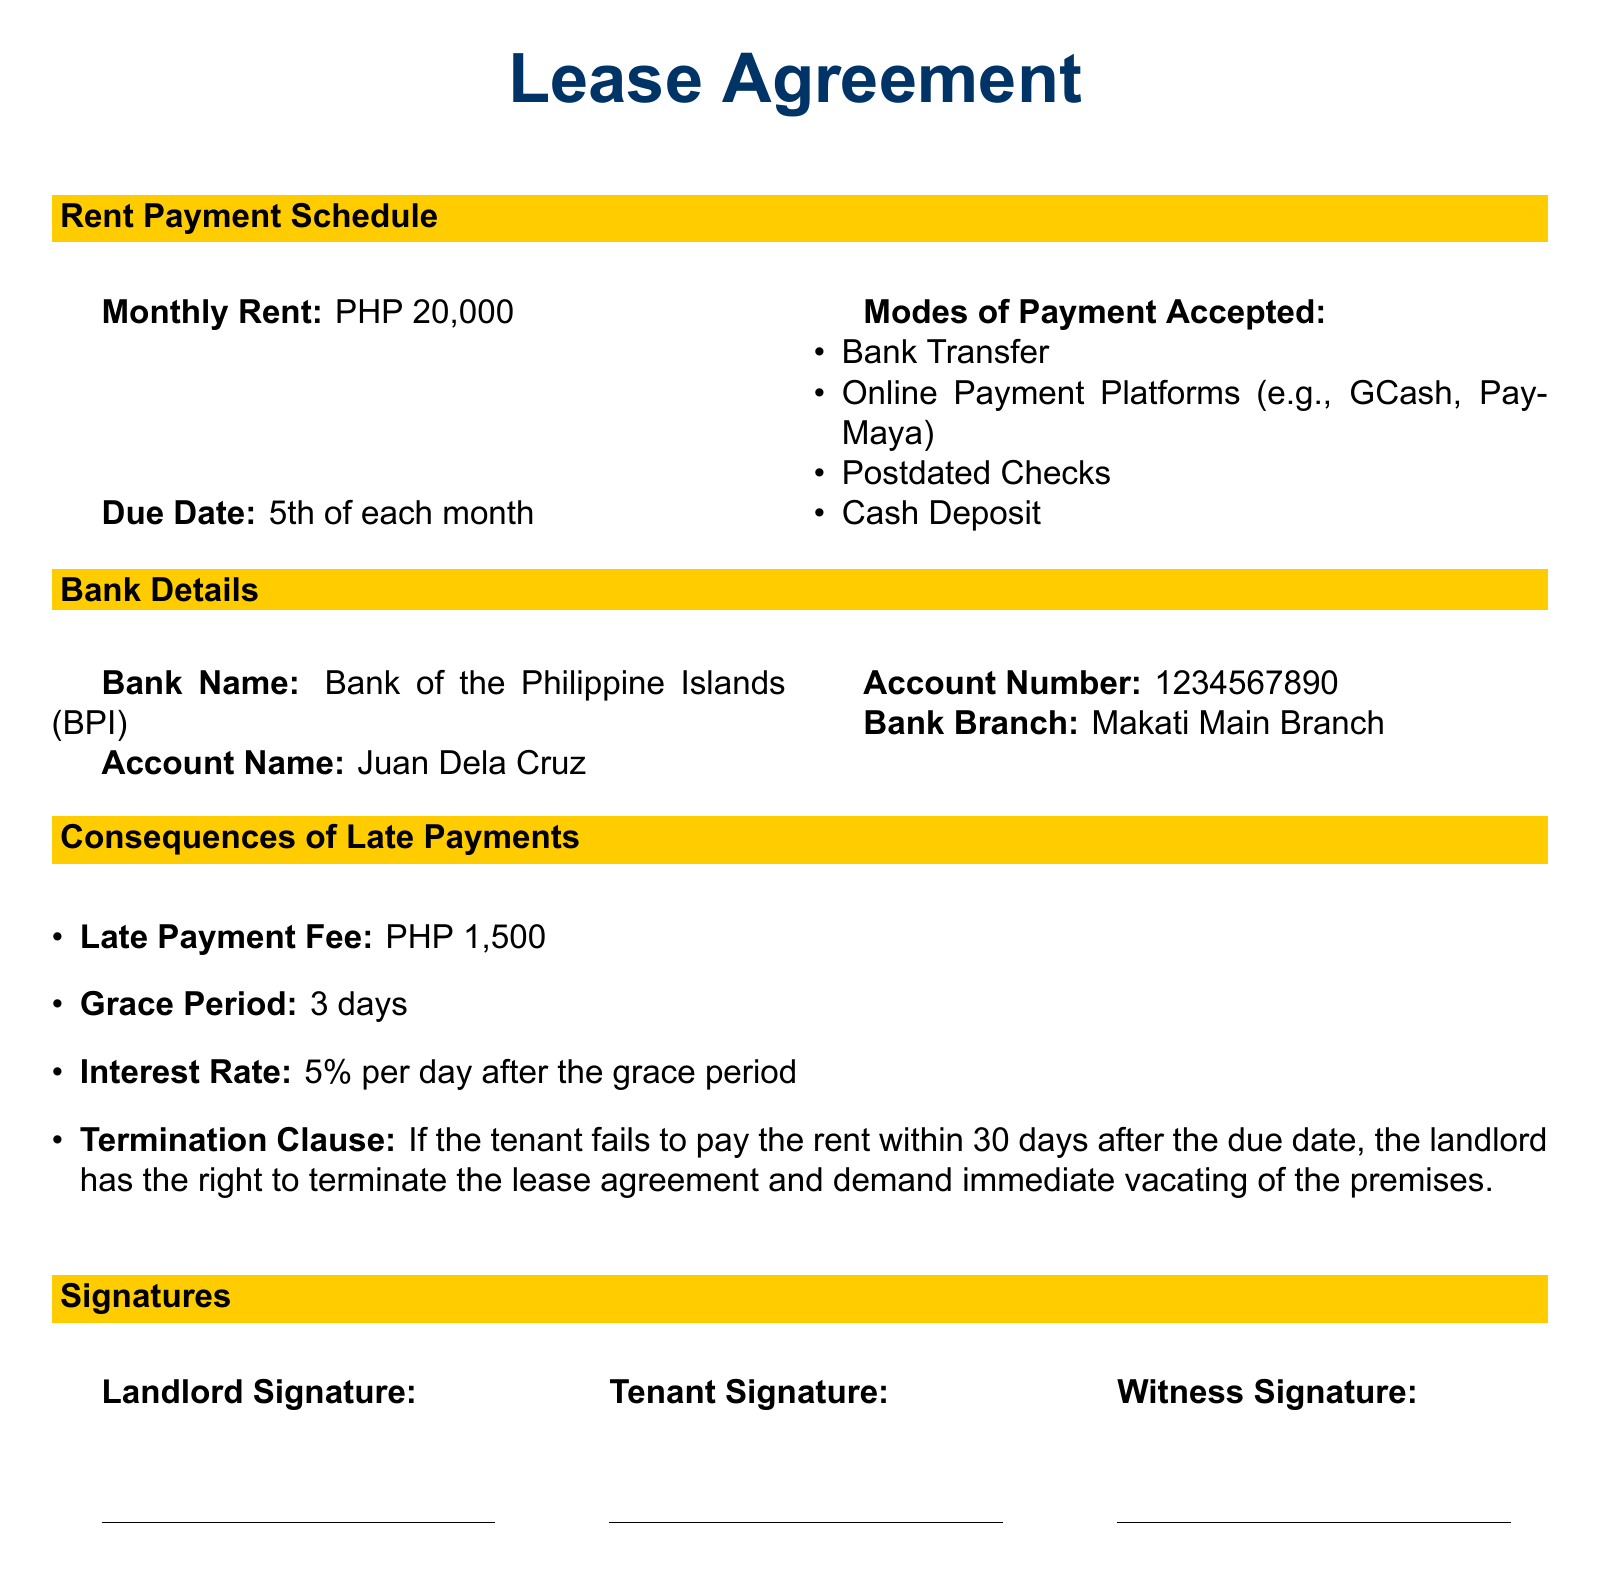What is the monthly rent? The monthly rent is stated explicitly in the document.
Answer: PHP 20,000 When is the rent due? The due date for rent is specified in the payment schedule.
Answer: 5th of each month What are the accepted modes of payment? The document lists the acceptable payment methods in a bullet format.
Answer: Bank Transfer, Online Payment Platforms, Postdated Checks, Cash Deposit What is the late payment fee? The document specifies the penalty for late payments clearly.
Answer: PHP 1,500 What is the grace period for late payments? The grace period is mentioned explicitly in the consequences section.
Answer: 3 days What is the interest rate after the grace period? The document states the interest rate applicable for late payments.
Answer: 5% per day What is the termination clause? The clause outlines the consequences of failing to pay rent within a specified timeframe.
Answer: Within 30 days after the due date Who is the account holder for bank payments? The document specifies the name of the account holder for bank transactions.
Answer: Juan Dela Cruz 